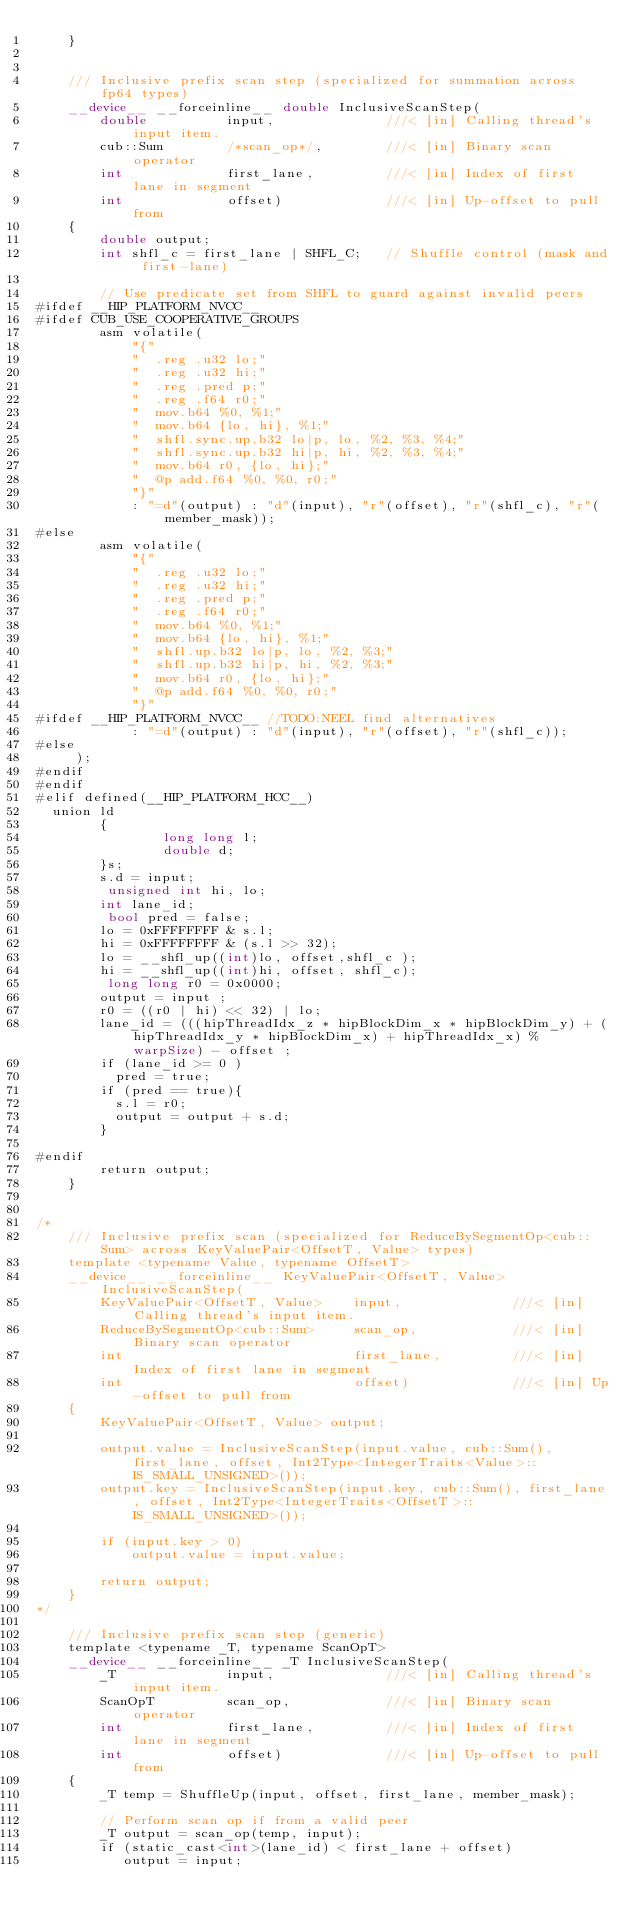<code> <loc_0><loc_0><loc_500><loc_500><_Cuda_>    }


    /// Inclusive prefix scan step (specialized for summation across fp64 types)
    __device__ __forceinline__ double InclusiveScanStep(
        double          input,              ///< [in] Calling thread's input item.
        cub::Sum        /*scan_op*/,        ///< [in] Binary scan operator
        int             first_lane,         ///< [in] Index of first lane in segment
        int             offset)             ///< [in] Up-offset to pull from
    {
        double output;
        int shfl_c = first_lane | SHFL_C;   // Shuffle control (mask and first-lane)

        // Use predicate set from SHFL to guard against invalid peers
#ifdef __HIP_PLATFORM_NVCC__
#ifdef CUB_USE_COOPERATIVE_GROUPS
        asm volatile(
            "{"
            "  .reg .u32 lo;"
            "  .reg .u32 hi;"
            "  .reg .pred p;"
            "  .reg .f64 r0;"
            "  mov.b64 %0, %1;"
            "  mov.b64 {lo, hi}, %1;"
            "  shfl.sync.up.b32 lo|p, lo, %2, %3, %4;"
            "  shfl.sync.up.b32 hi|p, hi, %2, %3, %4;"
            "  mov.b64 r0, {lo, hi};"
            "  @p add.f64 %0, %0, r0;"
            "}"
            : "=d"(output) : "d"(input), "r"(offset), "r"(shfl_c), "r"(member_mask));
#else
        asm volatile(
            "{"
            "  .reg .u32 lo;"
            "  .reg .u32 hi;"
            "  .reg .pred p;"
            "  .reg .f64 r0;"
            "  mov.b64 %0, %1;"
            "  mov.b64 {lo, hi}, %1;"
            "  shfl.up.b32 lo|p, lo, %2, %3;"
            "  shfl.up.b32 hi|p, hi, %2, %3;"
            "  mov.b64 r0, {lo, hi};"
            "  @p add.f64 %0, %0, r0;"
            "}"
#ifdef __HIP_PLATFORM_NVCC__ //TODO:NEEL find alternatives
            : "=d"(output) : "d"(input), "r"(offset), "r"(shfl_c));
#else
     );
#endif
#endif
#elif defined(__HIP_PLATFORM_HCC__)
	union ld
        {
                long long l;
                double d;
        }s;
        s.d = input;
         unsigned int hi, lo;
        int lane_id;
         bool pred = false;
        lo = 0xFFFFFFFF & s.l;
        hi = 0xFFFFFFFF & (s.l >> 32);
        lo = __shfl_up((int)lo, offset,shfl_c );
        hi = __shfl_up((int)hi, offset, shfl_c);
         long long r0 = 0x0000;
        output = input ;
        r0 = ((r0 | hi) << 32) | lo;
        lane_id = (((hipThreadIdx_z * hipBlockDim_x * hipBlockDim_y) + (hipThreadIdx_y * hipBlockDim_x) + hipThreadIdx_x) % warpSize) - offset ;
        if (lane_id >= 0 )
          pred = true;
        if (pred == true){
          s.l = r0;
          output = output + s.d;
        }

#endif
        return output;
    }


/*
    /// Inclusive prefix scan (specialized for ReduceBySegmentOp<cub::Sum> across KeyValuePair<OffsetT, Value> types)
    template <typename Value, typename OffsetT>
    __device__ __forceinline__ KeyValuePair<OffsetT, Value>InclusiveScanStep(
        KeyValuePair<OffsetT, Value>    input,              ///< [in] Calling thread's input item.
        ReduceBySegmentOp<cub::Sum>     scan_op,            ///< [in] Binary scan operator
        int                             first_lane,         ///< [in] Index of first lane in segment
        int                             offset)             ///< [in] Up-offset to pull from
    {
        KeyValuePair<OffsetT, Value> output;

        output.value = InclusiveScanStep(input.value, cub::Sum(), first_lane, offset, Int2Type<IntegerTraits<Value>::IS_SMALL_UNSIGNED>());
        output.key = InclusiveScanStep(input.key, cub::Sum(), first_lane, offset, Int2Type<IntegerTraits<OffsetT>::IS_SMALL_UNSIGNED>());

        if (input.key > 0)
            output.value = input.value;

        return output;
    }
*/

    /// Inclusive prefix scan step (generic)
    template <typename _T, typename ScanOpT>
    __device__ __forceinline__ _T InclusiveScanStep(
        _T              input,              ///< [in] Calling thread's input item.
        ScanOpT         scan_op,            ///< [in] Binary scan operator
        int             first_lane,         ///< [in] Index of first lane in segment
        int             offset)             ///< [in] Up-offset to pull from
    {
        _T temp = ShuffleUp(input, offset, first_lane, member_mask);

        // Perform scan op if from a valid peer
        _T output = scan_op(temp, input);
        if (static_cast<int>(lane_id) < first_lane + offset)
           output = input;
</code> 